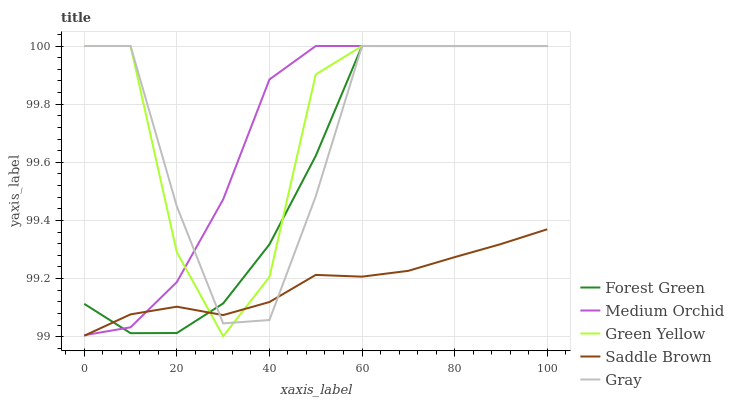Does Saddle Brown have the minimum area under the curve?
Answer yes or no. Yes. Does Green Yellow have the maximum area under the curve?
Answer yes or no. Yes. Does Forest Green have the minimum area under the curve?
Answer yes or no. No. Does Forest Green have the maximum area under the curve?
Answer yes or no. No. Is Saddle Brown the smoothest?
Answer yes or no. Yes. Is Green Yellow the roughest?
Answer yes or no. Yes. Is Forest Green the smoothest?
Answer yes or no. No. Is Forest Green the roughest?
Answer yes or no. No. Does Green Yellow have the lowest value?
Answer yes or no. Yes. Does Forest Green have the lowest value?
Answer yes or no. No. Does Green Yellow have the highest value?
Answer yes or no. Yes. Does Saddle Brown have the highest value?
Answer yes or no. No. Does Green Yellow intersect Gray?
Answer yes or no. Yes. Is Green Yellow less than Gray?
Answer yes or no. No. Is Green Yellow greater than Gray?
Answer yes or no. No. 